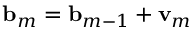<formula> <loc_0><loc_0><loc_500><loc_500>{ b } _ { m } = { b } _ { m - 1 } + { v } _ { m }</formula> 